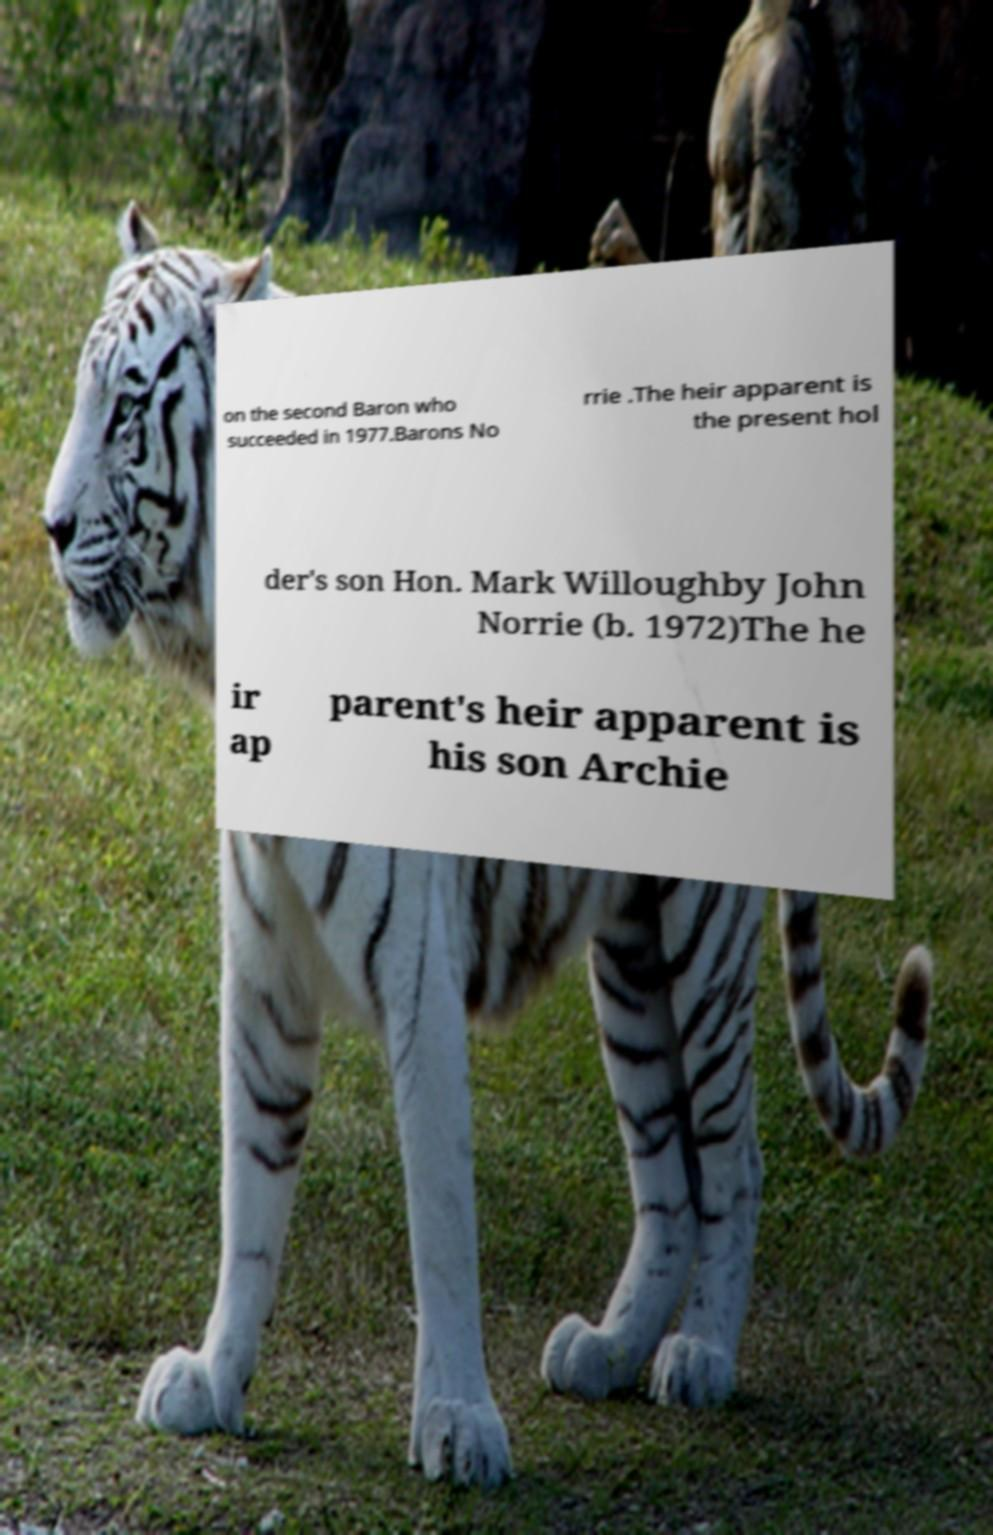Please identify and transcribe the text found in this image. on the second Baron who succeeded in 1977.Barons No rrie .The heir apparent is the present hol der's son Hon. Mark Willoughby John Norrie (b. 1972)The he ir ap parent's heir apparent is his son Archie 